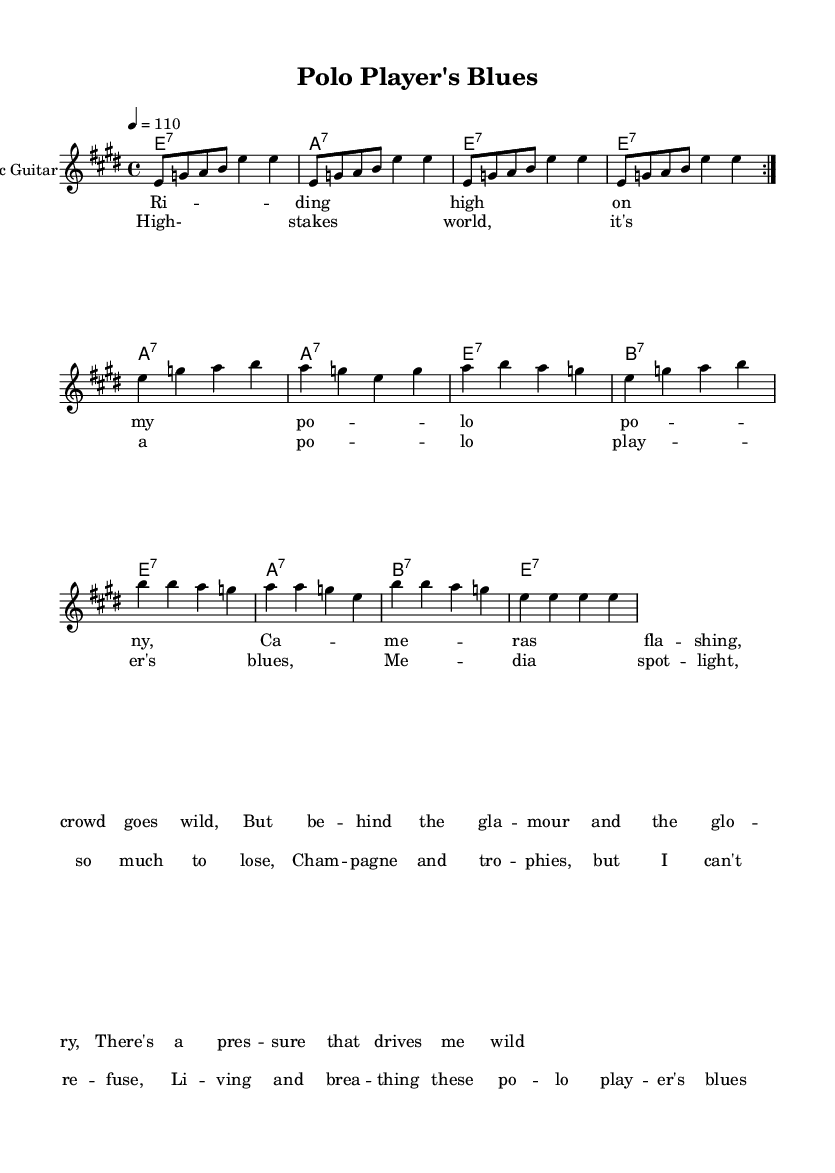What is the key signature of this music? The key signature is E major, which has four sharps: F#, C#, G#, and D#. This is indicated at the beginning of the staff, right after the clef.
Answer: E major What is the time signature of this music? The time signature is 4/4, which means there are four beats in a measure and the quarter note gets one beat. This is shown at the beginning of the staff, next to the key signature.
Answer: 4/4 What is the tempo marking of this music? The tempo marking is quarter note equals 110 beats per minute, indicated by "4 = 110" at the beginning of the score. This tells performers the speed at which to play.
Answer: 110 How many measures are there in the verse section? The verse section consists of four measures as can be seen when counting the bars in the lyric representation. Each line of lyrics corresponds to one measure.
Answer: 4 What are the first two chords in the song? The first two chords in the chord chart are E7 and A7, which are shown at the beginning of the chord row. Chords typically precede the section where they are played.
Answer: E7, A7 What is the lyrical theme of this piece? The lyrical theme revolves around the pressures and public scrutiny faced by a polo player, highlighting the contrast between fame and the struggles behind the scenes. This is evident in the lyrics' focus on high-stakes competition and media attention.
Answer: High-stakes world What style of music is represented in this sheet? This music is categorized as electric blues, characterized by its incorporation of electric guitar and themes specific to the struggles in a sport context—here, polo as a high-stakes sport.
Answer: Electric blues 